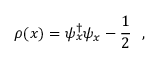<formula> <loc_0><loc_0><loc_500><loc_500>\rho ( x ) = \psi _ { x } ^ { \dag } \psi _ { x } - \frac { 1 } { 2 } \ \ ,</formula> 